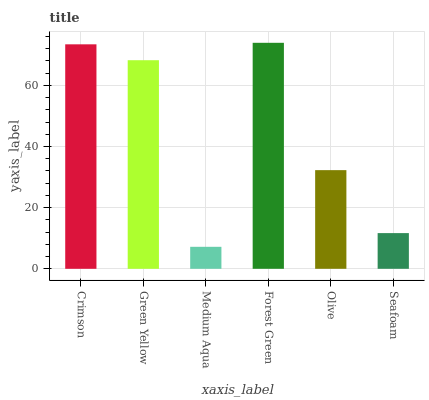Is Medium Aqua the minimum?
Answer yes or no. Yes. Is Forest Green the maximum?
Answer yes or no. Yes. Is Green Yellow the minimum?
Answer yes or no. No. Is Green Yellow the maximum?
Answer yes or no. No. Is Crimson greater than Green Yellow?
Answer yes or no. Yes. Is Green Yellow less than Crimson?
Answer yes or no. Yes. Is Green Yellow greater than Crimson?
Answer yes or no. No. Is Crimson less than Green Yellow?
Answer yes or no. No. Is Green Yellow the high median?
Answer yes or no. Yes. Is Olive the low median?
Answer yes or no. Yes. Is Seafoam the high median?
Answer yes or no. No. Is Forest Green the low median?
Answer yes or no. No. 